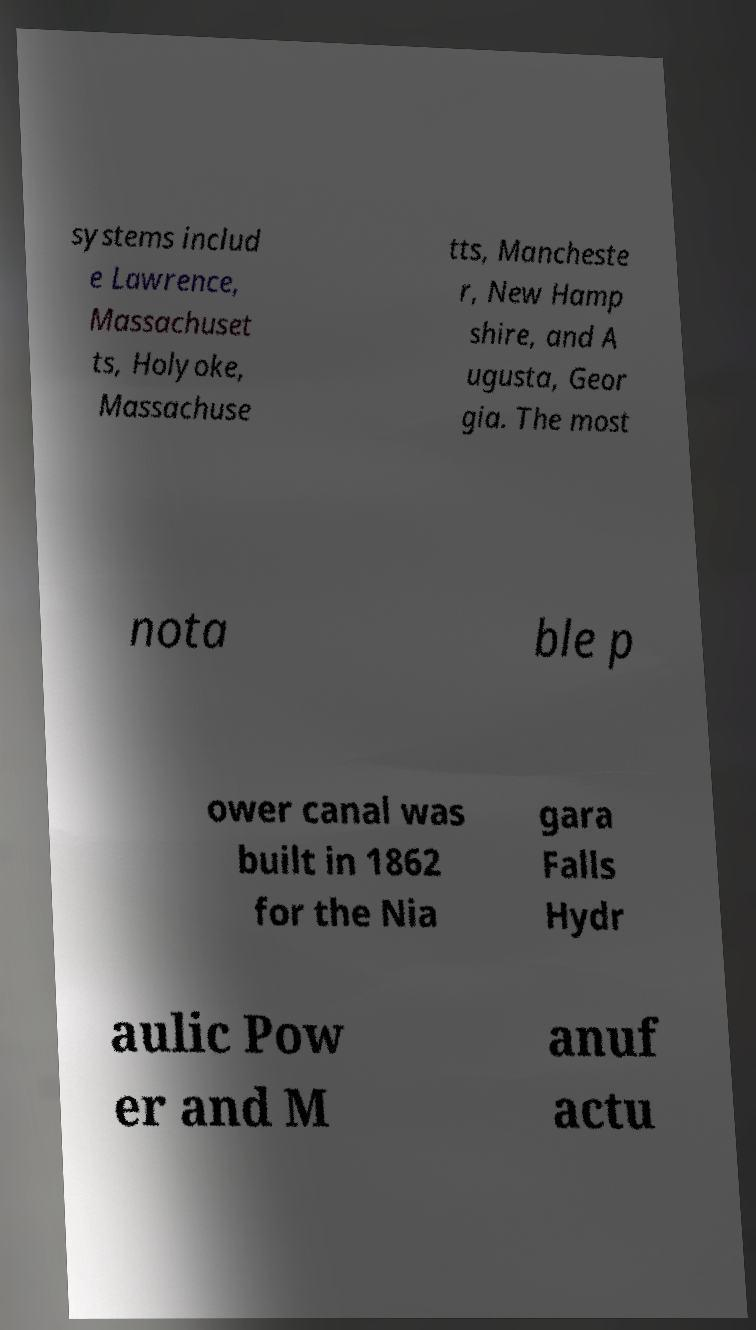Could you extract and type out the text from this image? systems includ e Lawrence, Massachuset ts, Holyoke, Massachuse tts, Mancheste r, New Hamp shire, and A ugusta, Geor gia. The most nota ble p ower canal was built in 1862 for the Nia gara Falls Hydr aulic Pow er and M anuf actu 